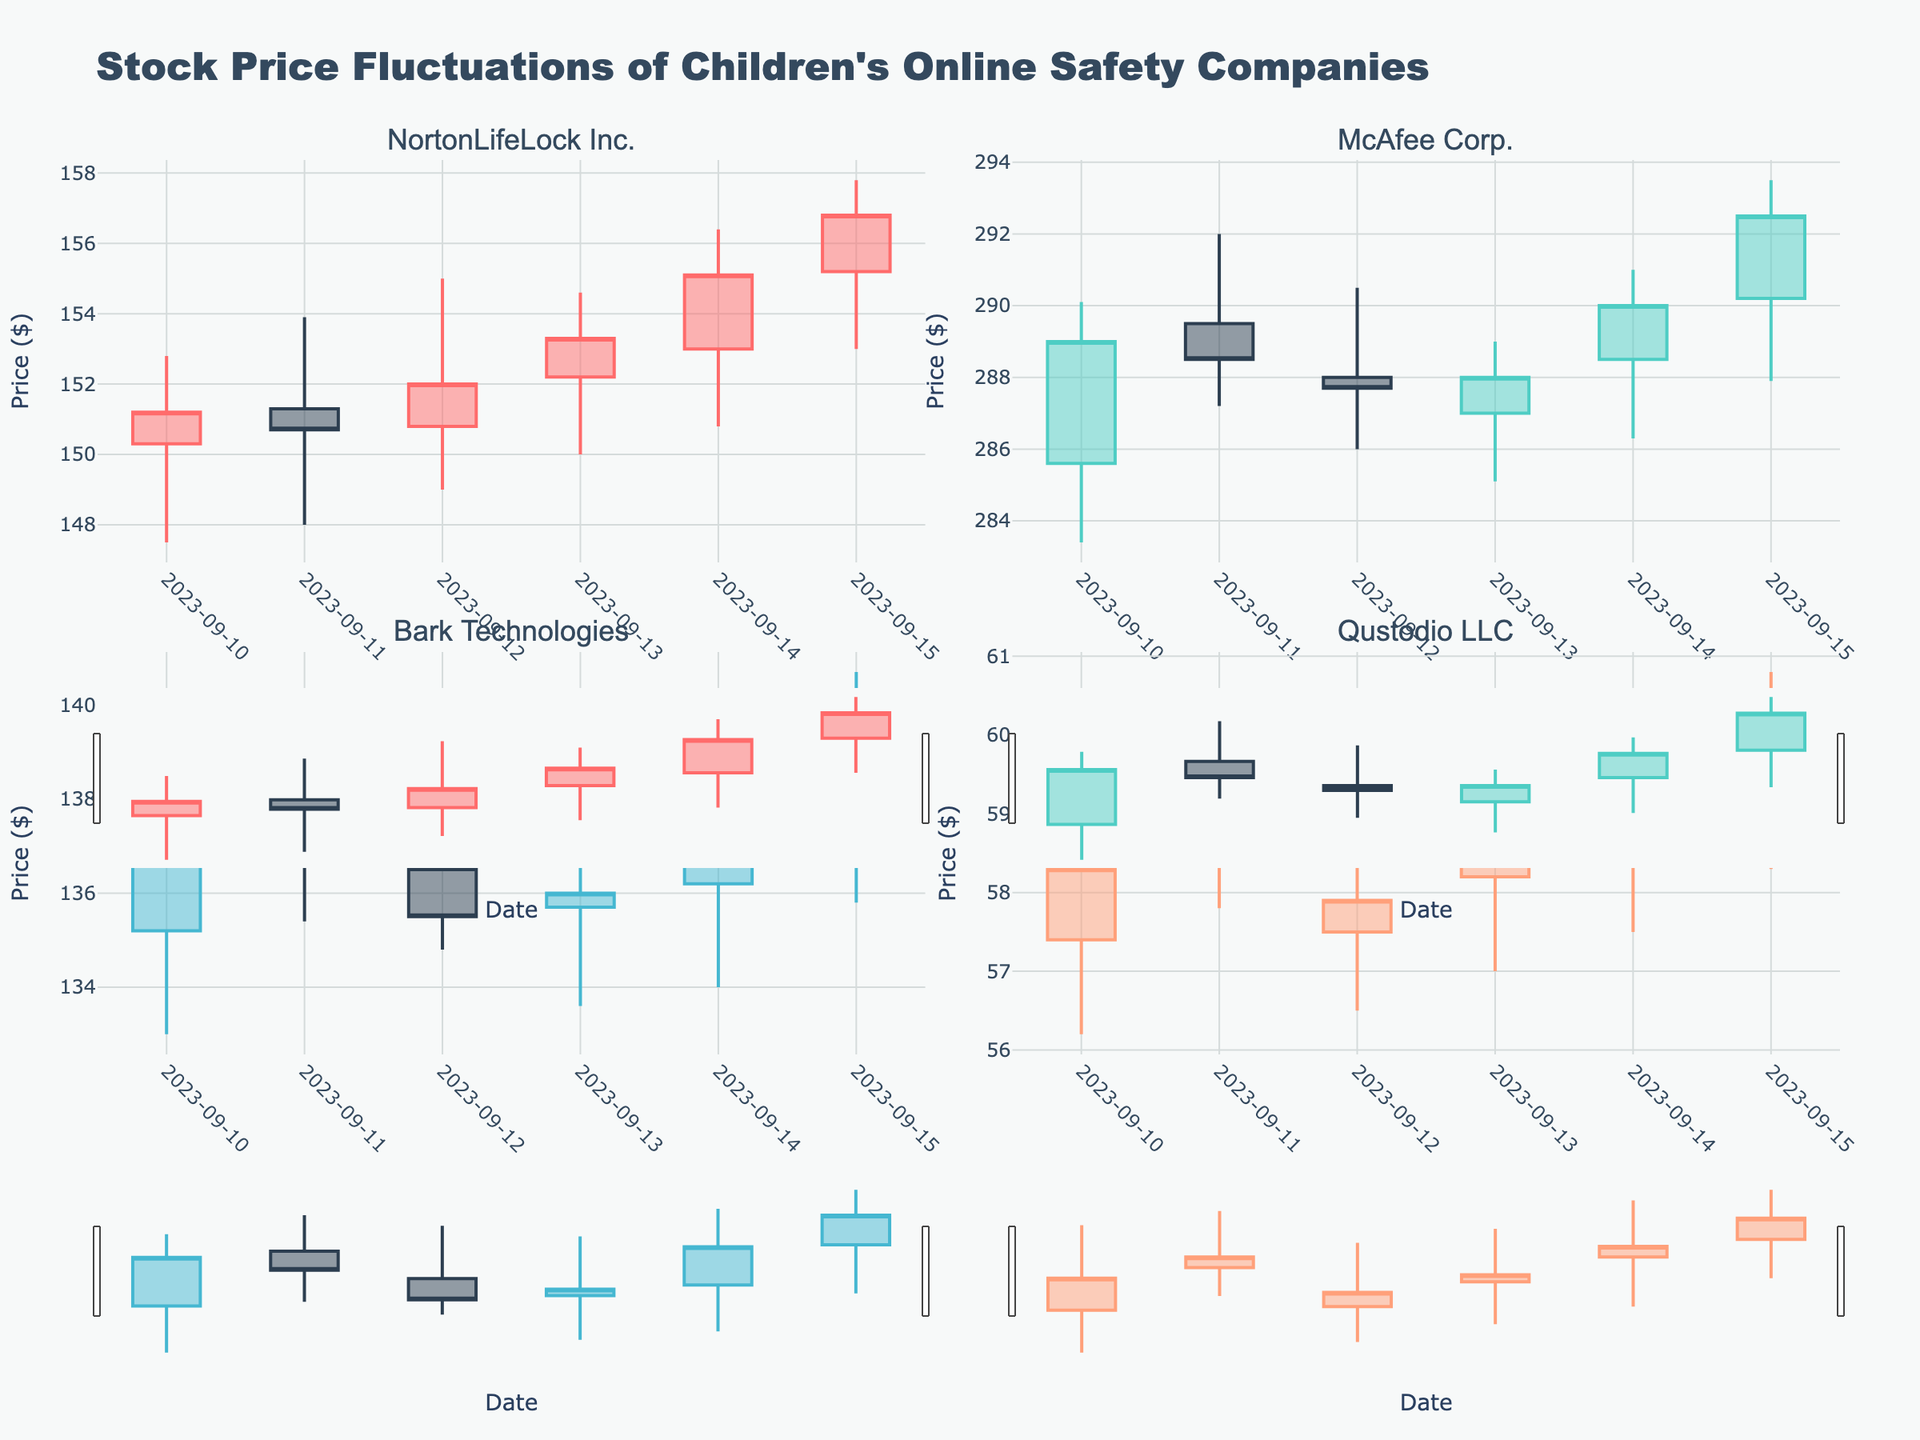What's the title of the chart? The title of the chart is located at the top-center of the plot and is typically bold and prominent. It provides the viewer with an overview of what the plot depicts.
Answer: Stock Price Fluctuations of Children's Online Safety Companies On which date did Norton's stock price close the highest? To find the highest closing price for Norton, examine the closing prices for NortonLifeLock Inc. on all dates and identify the maximum value.
Answer: 2023-09-15 What is the price range (difference between high and low) for Qustodio on 2023-09-15? To determine the price range, subtract the lowest price from the highest price for Qustodio LLC on 2023-09-15: High (60.80) - Low (58.30) = 2.50.
Answer: $2.50 Which company had the highest average closing price over the given dates? Calculate the average closing price for each company over the dates provided, then compare these averages to identify the highest. McAfee: (289.00 + 288.50 + 287.70 + 288.00 + 290.00 + 292.50) / 6 = 289.62; Norton: (151.20 + 150.70 + 152.00 + 153.30 + 155.10 + 156.80) / 6 = 153.52; Bark: (137.50 + 136.90 + 135.50 + 136.00 + 138.00 + 139.50) / 6 = 137.57; Qustodio: (58.30 + 58.90 + 57.90 + 58.40 + 59.20 + 60.00) / 6 = 58.78; McAfee has the highest average closing price.
Answer: McAfee Corp Did any company's stock show an overall upward trend in closing prices over the five-day period? For each company, examine the closing prices from the start date to the end date to identify an upward trend, where each price is higher than the previous day's. Norton: 151.20, 150.70, 152.00, 153.30, 155.10, 156.80 (Upward); McAfee: 289.00, 288.50, 287.70, 288.00, 290.00, 292.50 (Upward); Bark: 137.50, 136.90, 135.50, 136.00, 138.00, 139.50 (Mixed); Qustodio: 58.30, 58.90, 57.90, 58.40, 59.20, 60.00 (Upward); All companies except Bark.
Answer: NortonLifeLock Inc., McAfee Corp., Qustodio LLC Which company experienced the most significant drop in closing price from one day to the next? Identify the largest drop in closing prices for each company from one day to the next and compare these values to find the largest. Norton: 151.20 to 150.70 = 0.50; McAfee: 289.00 to 288.50 = 0.50; Bark: 137.50 to 136.90 = 0.60; Qustodio: 58.90 to 57.90 = 1.00; Qustodio experienced the most significant drop.
Answer: Qustodio LLC On which date did Bark Technologies have the lowest opening price? Check the opening prices for Bark Technologies on all dates and identify the lowest one. The dates and corresponding opening prices are: 2023-09-10 (135.20), 2023-09-11 (137.80), 2023-09-12 (136.50), 2023-09-13 (135.70), 2023-09-14 (136.20), and 2023-09-15 (138.10).
Answer: 2023-09-10 How many companies had their stock price close higher on 2023-09-13 compared to 2023-09-12? Compare the closing prices on 2023-09-13 to the closing prices on 2023-09-12 for each company. Norton: 153.30 > 152.00; McAfee: 288.00 > 287.70; Bark: 136.00 > 135.50; Qustodio: 58.40 > 57.90; All four companies had a higher closing price on 2023-09-13.
Answer: Four 